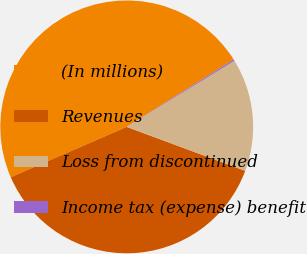<chart> <loc_0><loc_0><loc_500><loc_500><pie_chart><fcel>(In millions)<fcel>Revenues<fcel>Loss from discontinued<fcel>Income tax (expense) benefit<nl><fcel>47.58%<fcel>37.83%<fcel>14.41%<fcel>0.19%<nl></chart> 